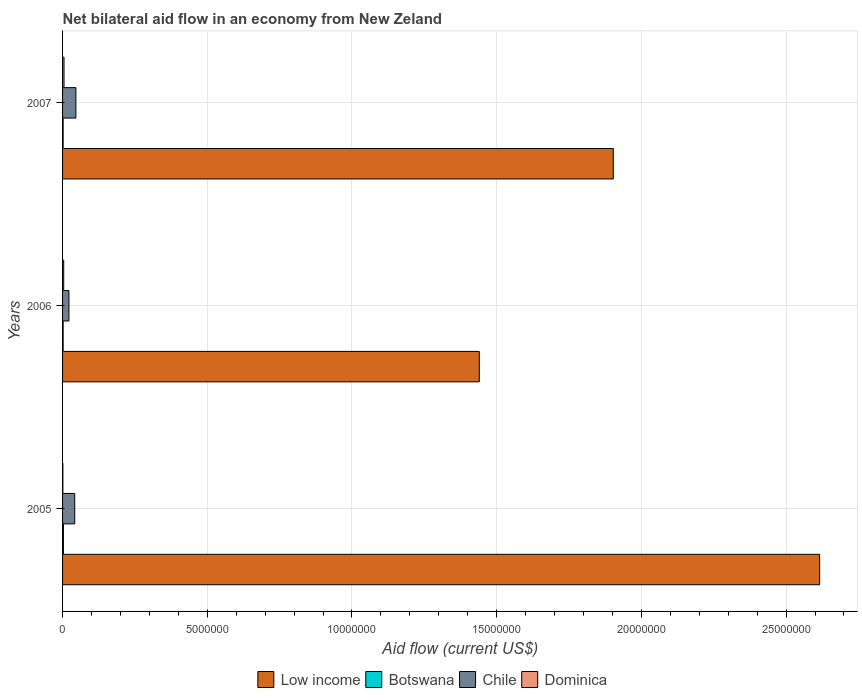How many different coloured bars are there?
Make the answer very short. 4. How many groups of bars are there?
Make the answer very short. 3. How many bars are there on the 3rd tick from the top?
Your answer should be compact. 4. How many bars are there on the 3rd tick from the bottom?
Offer a terse response. 4. What is the net bilateral aid flow in Chile in 2007?
Your response must be concise. 4.60e+05. In which year was the net bilateral aid flow in Low income minimum?
Offer a very short reply. 2006. What is the total net bilateral aid flow in Botswana in the graph?
Your response must be concise. 7.00e+04. What is the difference between the net bilateral aid flow in Dominica in 2005 and the net bilateral aid flow in Low income in 2007?
Provide a short and direct response. -1.90e+07. What is the average net bilateral aid flow in Botswana per year?
Your answer should be very brief. 2.33e+04. In the year 2007, what is the difference between the net bilateral aid flow in Low income and net bilateral aid flow in Botswana?
Provide a succinct answer. 1.90e+07. What is the ratio of the net bilateral aid flow in Chile in 2005 to that in 2007?
Your response must be concise. 0.91. Is the net bilateral aid flow in Chile in 2005 less than that in 2006?
Keep it short and to the point. No. Is the difference between the net bilateral aid flow in Low income in 2005 and 2007 greater than the difference between the net bilateral aid flow in Botswana in 2005 and 2007?
Your answer should be compact. Yes. What is the difference between the highest and the second highest net bilateral aid flow in Dominica?
Your response must be concise. 10000. Is the sum of the net bilateral aid flow in Chile in 2005 and 2007 greater than the maximum net bilateral aid flow in Botswana across all years?
Your answer should be compact. Yes. Is it the case that in every year, the sum of the net bilateral aid flow in Low income and net bilateral aid flow in Botswana is greater than the sum of net bilateral aid flow in Chile and net bilateral aid flow in Dominica?
Give a very brief answer. Yes. What does the 4th bar from the bottom in 2005 represents?
Provide a succinct answer. Dominica. Is it the case that in every year, the sum of the net bilateral aid flow in Low income and net bilateral aid flow in Botswana is greater than the net bilateral aid flow in Chile?
Make the answer very short. Yes. Are all the bars in the graph horizontal?
Offer a terse response. Yes. How many years are there in the graph?
Make the answer very short. 3. What is the difference between two consecutive major ticks on the X-axis?
Offer a very short reply. 5.00e+06. Are the values on the major ticks of X-axis written in scientific E-notation?
Your answer should be compact. No. Does the graph contain any zero values?
Your response must be concise. No. How many legend labels are there?
Keep it short and to the point. 4. How are the legend labels stacked?
Provide a succinct answer. Horizontal. What is the title of the graph?
Offer a very short reply. Net bilateral aid flow in an economy from New Zeland. What is the label or title of the X-axis?
Your response must be concise. Aid flow (current US$). What is the Aid flow (current US$) of Low income in 2005?
Keep it short and to the point. 2.62e+07. What is the Aid flow (current US$) of Botswana in 2005?
Your answer should be very brief. 3.00e+04. What is the Aid flow (current US$) of Chile in 2005?
Give a very brief answer. 4.20e+05. What is the Aid flow (current US$) of Dominica in 2005?
Provide a succinct answer. 10000. What is the Aid flow (current US$) of Low income in 2006?
Give a very brief answer. 1.44e+07. What is the Aid flow (current US$) of Chile in 2006?
Give a very brief answer. 2.20e+05. What is the Aid flow (current US$) of Low income in 2007?
Offer a very short reply. 1.90e+07. Across all years, what is the maximum Aid flow (current US$) in Low income?
Your answer should be very brief. 2.62e+07. Across all years, what is the minimum Aid flow (current US$) in Low income?
Your response must be concise. 1.44e+07. Across all years, what is the minimum Aid flow (current US$) in Botswana?
Your response must be concise. 2.00e+04. What is the total Aid flow (current US$) in Low income in the graph?
Provide a succinct answer. 5.96e+07. What is the total Aid flow (current US$) of Chile in the graph?
Ensure brevity in your answer.  1.10e+06. What is the difference between the Aid flow (current US$) of Low income in 2005 and that in 2006?
Keep it short and to the point. 1.18e+07. What is the difference between the Aid flow (current US$) of Botswana in 2005 and that in 2006?
Ensure brevity in your answer.  10000. What is the difference between the Aid flow (current US$) in Chile in 2005 and that in 2006?
Keep it short and to the point. 2.00e+05. What is the difference between the Aid flow (current US$) of Dominica in 2005 and that in 2006?
Offer a terse response. -3.00e+04. What is the difference between the Aid flow (current US$) of Low income in 2005 and that in 2007?
Your answer should be compact. 7.13e+06. What is the difference between the Aid flow (current US$) in Chile in 2005 and that in 2007?
Make the answer very short. -4.00e+04. What is the difference between the Aid flow (current US$) in Dominica in 2005 and that in 2007?
Give a very brief answer. -4.00e+04. What is the difference between the Aid flow (current US$) in Low income in 2006 and that in 2007?
Your response must be concise. -4.63e+06. What is the difference between the Aid flow (current US$) of Low income in 2005 and the Aid flow (current US$) of Botswana in 2006?
Give a very brief answer. 2.61e+07. What is the difference between the Aid flow (current US$) in Low income in 2005 and the Aid flow (current US$) in Chile in 2006?
Your answer should be very brief. 2.59e+07. What is the difference between the Aid flow (current US$) in Low income in 2005 and the Aid flow (current US$) in Dominica in 2006?
Keep it short and to the point. 2.61e+07. What is the difference between the Aid flow (current US$) in Botswana in 2005 and the Aid flow (current US$) in Dominica in 2006?
Ensure brevity in your answer.  -10000. What is the difference between the Aid flow (current US$) of Low income in 2005 and the Aid flow (current US$) of Botswana in 2007?
Make the answer very short. 2.61e+07. What is the difference between the Aid flow (current US$) of Low income in 2005 and the Aid flow (current US$) of Chile in 2007?
Your answer should be compact. 2.57e+07. What is the difference between the Aid flow (current US$) in Low income in 2005 and the Aid flow (current US$) in Dominica in 2007?
Your response must be concise. 2.61e+07. What is the difference between the Aid flow (current US$) in Botswana in 2005 and the Aid flow (current US$) in Chile in 2007?
Offer a terse response. -4.30e+05. What is the difference between the Aid flow (current US$) in Botswana in 2005 and the Aid flow (current US$) in Dominica in 2007?
Make the answer very short. -2.00e+04. What is the difference between the Aid flow (current US$) in Chile in 2005 and the Aid flow (current US$) in Dominica in 2007?
Offer a very short reply. 3.70e+05. What is the difference between the Aid flow (current US$) in Low income in 2006 and the Aid flow (current US$) in Botswana in 2007?
Offer a terse response. 1.44e+07. What is the difference between the Aid flow (current US$) in Low income in 2006 and the Aid flow (current US$) in Chile in 2007?
Give a very brief answer. 1.39e+07. What is the difference between the Aid flow (current US$) of Low income in 2006 and the Aid flow (current US$) of Dominica in 2007?
Make the answer very short. 1.44e+07. What is the difference between the Aid flow (current US$) of Botswana in 2006 and the Aid flow (current US$) of Chile in 2007?
Your answer should be compact. -4.40e+05. What is the difference between the Aid flow (current US$) of Botswana in 2006 and the Aid flow (current US$) of Dominica in 2007?
Your response must be concise. -3.00e+04. What is the difference between the Aid flow (current US$) in Chile in 2006 and the Aid flow (current US$) in Dominica in 2007?
Keep it short and to the point. 1.70e+05. What is the average Aid flow (current US$) of Low income per year?
Provide a succinct answer. 1.99e+07. What is the average Aid flow (current US$) in Botswana per year?
Your response must be concise. 2.33e+04. What is the average Aid flow (current US$) in Chile per year?
Give a very brief answer. 3.67e+05. What is the average Aid flow (current US$) in Dominica per year?
Your answer should be very brief. 3.33e+04. In the year 2005, what is the difference between the Aid flow (current US$) in Low income and Aid flow (current US$) in Botswana?
Keep it short and to the point. 2.61e+07. In the year 2005, what is the difference between the Aid flow (current US$) in Low income and Aid flow (current US$) in Chile?
Keep it short and to the point. 2.57e+07. In the year 2005, what is the difference between the Aid flow (current US$) in Low income and Aid flow (current US$) in Dominica?
Give a very brief answer. 2.62e+07. In the year 2005, what is the difference between the Aid flow (current US$) of Botswana and Aid flow (current US$) of Chile?
Provide a short and direct response. -3.90e+05. In the year 2005, what is the difference between the Aid flow (current US$) in Chile and Aid flow (current US$) in Dominica?
Give a very brief answer. 4.10e+05. In the year 2006, what is the difference between the Aid flow (current US$) in Low income and Aid flow (current US$) in Botswana?
Keep it short and to the point. 1.44e+07. In the year 2006, what is the difference between the Aid flow (current US$) in Low income and Aid flow (current US$) in Chile?
Your answer should be compact. 1.42e+07. In the year 2006, what is the difference between the Aid flow (current US$) of Low income and Aid flow (current US$) of Dominica?
Keep it short and to the point. 1.44e+07. In the year 2006, what is the difference between the Aid flow (current US$) in Botswana and Aid flow (current US$) in Chile?
Offer a terse response. -2.00e+05. In the year 2007, what is the difference between the Aid flow (current US$) of Low income and Aid flow (current US$) of Botswana?
Your answer should be very brief. 1.90e+07. In the year 2007, what is the difference between the Aid flow (current US$) in Low income and Aid flow (current US$) in Chile?
Give a very brief answer. 1.86e+07. In the year 2007, what is the difference between the Aid flow (current US$) of Low income and Aid flow (current US$) of Dominica?
Keep it short and to the point. 1.90e+07. In the year 2007, what is the difference between the Aid flow (current US$) in Botswana and Aid flow (current US$) in Chile?
Your answer should be very brief. -4.40e+05. In the year 2007, what is the difference between the Aid flow (current US$) in Chile and Aid flow (current US$) in Dominica?
Give a very brief answer. 4.10e+05. What is the ratio of the Aid flow (current US$) in Low income in 2005 to that in 2006?
Offer a very short reply. 1.82. What is the ratio of the Aid flow (current US$) in Chile in 2005 to that in 2006?
Your response must be concise. 1.91. What is the ratio of the Aid flow (current US$) of Dominica in 2005 to that in 2006?
Make the answer very short. 0.25. What is the ratio of the Aid flow (current US$) in Low income in 2005 to that in 2007?
Ensure brevity in your answer.  1.37. What is the ratio of the Aid flow (current US$) in Botswana in 2005 to that in 2007?
Make the answer very short. 1.5. What is the ratio of the Aid flow (current US$) of Chile in 2005 to that in 2007?
Provide a short and direct response. 0.91. What is the ratio of the Aid flow (current US$) of Dominica in 2005 to that in 2007?
Offer a very short reply. 0.2. What is the ratio of the Aid flow (current US$) in Low income in 2006 to that in 2007?
Keep it short and to the point. 0.76. What is the ratio of the Aid flow (current US$) of Botswana in 2006 to that in 2007?
Make the answer very short. 1. What is the ratio of the Aid flow (current US$) in Chile in 2006 to that in 2007?
Your response must be concise. 0.48. What is the ratio of the Aid flow (current US$) in Dominica in 2006 to that in 2007?
Give a very brief answer. 0.8. What is the difference between the highest and the second highest Aid flow (current US$) of Low income?
Offer a terse response. 7.13e+06. What is the difference between the highest and the second highest Aid flow (current US$) of Chile?
Keep it short and to the point. 4.00e+04. What is the difference between the highest and the lowest Aid flow (current US$) in Low income?
Your answer should be compact. 1.18e+07. What is the difference between the highest and the lowest Aid flow (current US$) in Botswana?
Ensure brevity in your answer.  10000. 